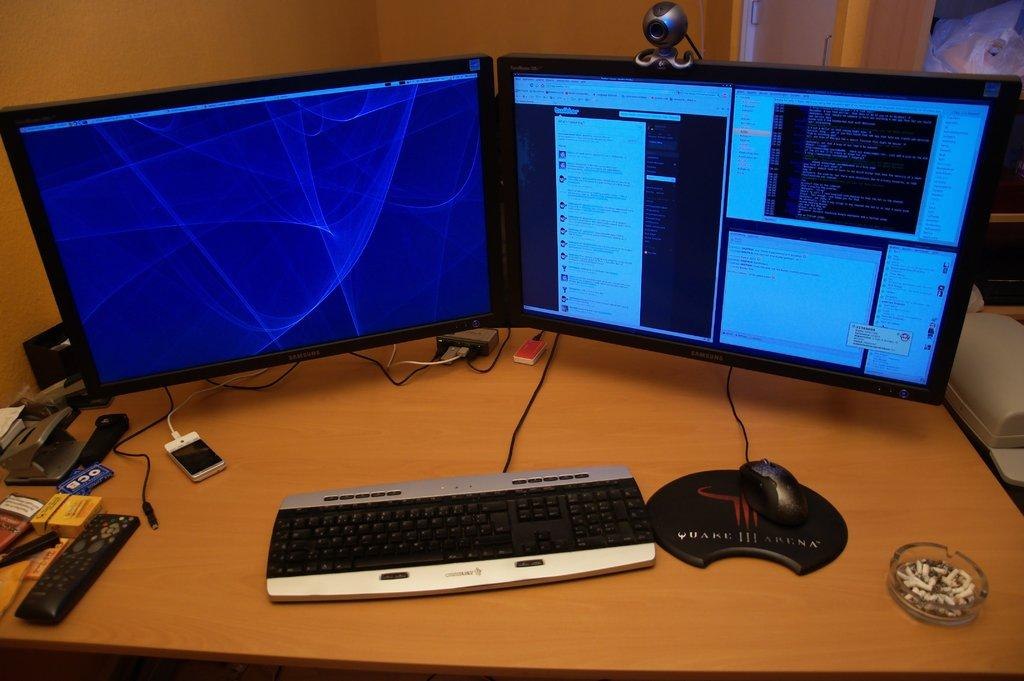<image>
Describe the image concisely. A mousepad advertising the game Quake III and two monitors 